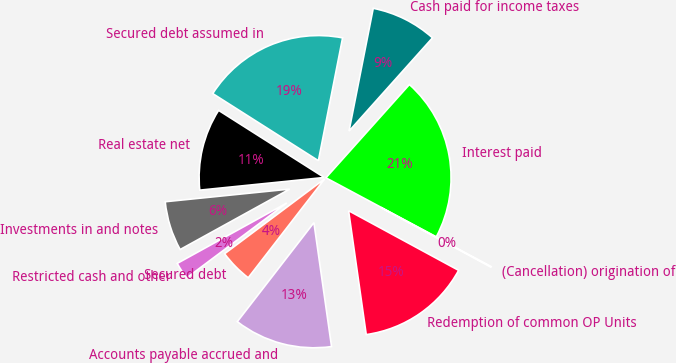<chart> <loc_0><loc_0><loc_500><loc_500><pie_chart><fcel>Interest paid<fcel>Cash paid for income taxes<fcel>Secured debt assumed in<fcel>Real estate net<fcel>Investments in and notes<fcel>Restricted cash and other<fcel>Secured debt<fcel>Accounts payable accrued and<fcel>Redemption of common OP Units<fcel>(Cancellation) origination of<nl><fcel>21.2%<fcel>8.52%<fcel>19.09%<fcel>10.62%<fcel>6.41%<fcel>2.2%<fcel>4.3%<fcel>12.73%<fcel>14.84%<fcel>0.09%<nl></chart> 